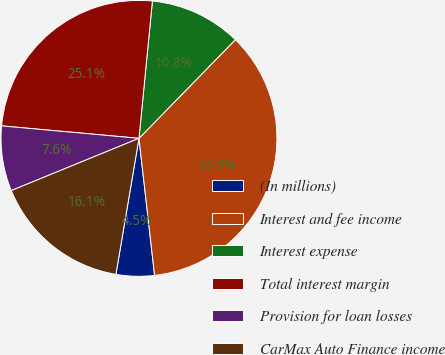Convert chart to OTSL. <chart><loc_0><loc_0><loc_500><loc_500><pie_chart><fcel>(In millions)<fcel>Interest and fee income<fcel>Interest expense<fcel>Total interest margin<fcel>Provision for loan losses<fcel>CarMax Auto Finance income<nl><fcel>4.48%<fcel>35.87%<fcel>10.76%<fcel>25.11%<fcel>7.62%<fcel>16.14%<nl></chart> 